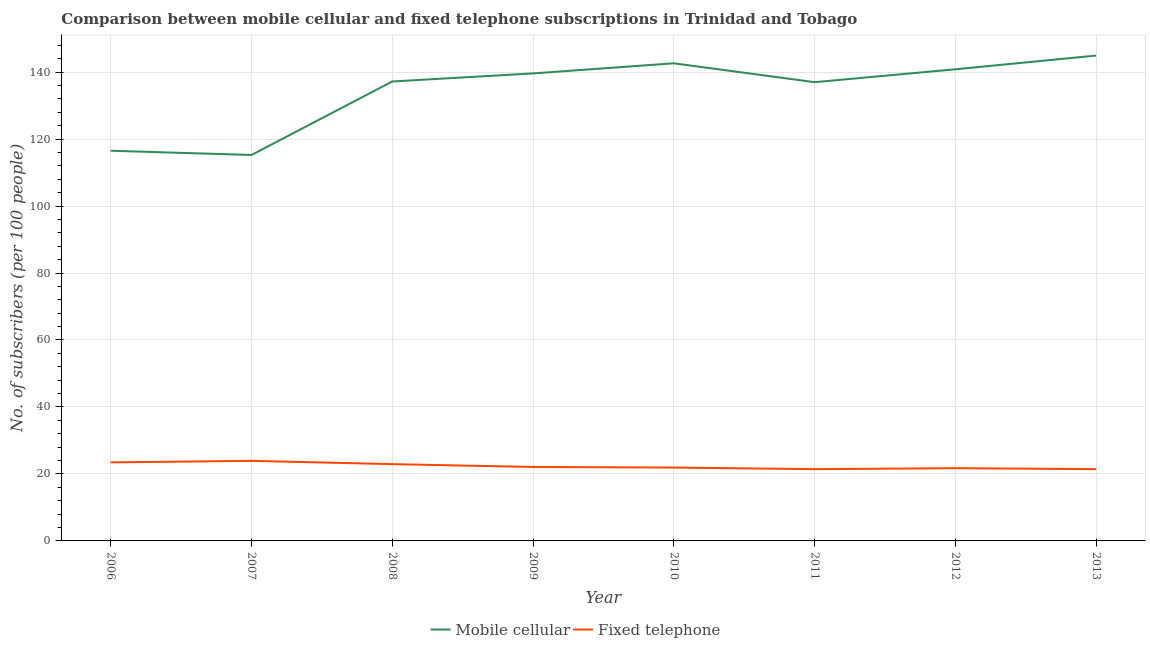How many different coloured lines are there?
Keep it short and to the point. 2. Is the number of lines equal to the number of legend labels?
Give a very brief answer. Yes. What is the number of fixed telephone subscribers in 2012?
Your answer should be very brief. 21.72. Across all years, what is the maximum number of fixed telephone subscribers?
Ensure brevity in your answer.  23.91. Across all years, what is the minimum number of fixed telephone subscribers?
Provide a succinct answer. 21.43. What is the total number of mobile cellular subscribers in the graph?
Provide a succinct answer. 1073.97. What is the difference between the number of fixed telephone subscribers in 2009 and that in 2013?
Your answer should be compact. 0.65. What is the difference between the number of fixed telephone subscribers in 2013 and the number of mobile cellular subscribers in 2010?
Provide a short and direct response. -121.19. What is the average number of mobile cellular subscribers per year?
Ensure brevity in your answer.  134.25. In the year 2011, what is the difference between the number of fixed telephone subscribers and number of mobile cellular subscribers?
Keep it short and to the point. -115.56. In how many years, is the number of fixed telephone subscribers greater than 104?
Make the answer very short. 0. What is the ratio of the number of mobile cellular subscribers in 2007 to that in 2010?
Ensure brevity in your answer.  0.81. Is the number of mobile cellular subscribers in 2009 less than that in 2012?
Make the answer very short. Yes. Is the difference between the number of mobile cellular subscribers in 2010 and 2013 greater than the difference between the number of fixed telephone subscribers in 2010 and 2013?
Provide a succinct answer. No. What is the difference between the highest and the second highest number of mobile cellular subscribers?
Ensure brevity in your answer.  2.31. What is the difference between the highest and the lowest number of fixed telephone subscribers?
Your response must be concise. 2.48. In how many years, is the number of mobile cellular subscribers greater than the average number of mobile cellular subscribers taken over all years?
Keep it short and to the point. 6. Is the sum of the number of fixed telephone subscribers in 2008 and 2010 greater than the maximum number of mobile cellular subscribers across all years?
Make the answer very short. No. Does the number of mobile cellular subscribers monotonically increase over the years?
Give a very brief answer. No. What is the difference between two consecutive major ticks on the Y-axis?
Ensure brevity in your answer.  20. Are the values on the major ticks of Y-axis written in scientific E-notation?
Offer a terse response. No. Does the graph contain any zero values?
Make the answer very short. No. Where does the legend appear in the graph?
Keep it short and to the point. Bottom center. How many legend labels are there?
Provide a short and direct response. 2. How are the legend labels stacked?
Ensure brevity in your answer.  Horizontal. What is the title of the graph?
Your answer should be very brief. Comparison between mobile cellular and fixed telephone subscriptions in Trinidad and Tobago. Does "Fraud firms" appear as one of the legend labels in the graph?
Offer a terse response. No. What is the label or title of the X-axis?
Provide a succinct answer. Year. What is the label or title of the Y-axis?
Your answer should be compact. No. of subscribers (per 100 people). What is the No. of subscribers (per 100 people) in Mobile cellular in 2006?
Keep it short and to the point. 116.52. What is the No. of subscribers (per 100 people) in Fixed telephone in 2006?
Make the answer very short. 23.46. What is the No. of subscribers (per 100 people) of Mobile cellular in 2007?
Your response must be concise. 115.25. What is the No. of subscribers (per 100 people) in Fixed telephone in 2007?
Your response must be concise. 23.91. What is the No. of subscribers (per 100 people) in Mobile cellular in 2008?
Offer a very short reply. 137.2. What is the No. of subscribers (per 100 people) of Fixed telephone in 2008?
Provide a short and direct response. 22.93. What is the No. of subscribers (per 100 people) of Mobile cellular in 2009?
Provide a succinct answer. 139.61. What is the No. of subscribers (per 100 people) of Fixed telephone in 2009?
Provide a short and direct response. 22.09. What is the No. of subscribers (per 100 people) in Mobile cellular in 2010?
Offer a terse response. 142.63. What is the No. of subscribers (per 100 people) in Fixed telephone in 2010?
Ensure brevity in your answer.  21.91. What is the No. of subscribers (per 100 people) of Mobile cellular in 2011?
Make the answer very short. 136.99. What is the No. of subscribers (per 100 people) of Fixed telephone in 2011?
Give a very brief answer. 21.43. What is the No. of subscribers (per 100 people) of Mobile cellular in 2012?
Offer a terse response. 140.84. What is the No. of subscribers (per 100 people) of Fixed telephone in 2012?
Ensure brevity in your answer.  21.72. What is the No. of subscribers (per 100 people) in Mobile cellular in 2013?
Make the answer very short. 144.94. What is the No. of subscribers (per 100 people) of Fixed telephone in 2013?
Your response must be concise. 21.43. Across all years, what is the maximum No. of subscribers (per 100 people) in Mobile cellular?
Offer a terse response. 144.94. Across all years, what is the maximum No. of subscribers (per 100 people) in Fixed telephone?
Provide a succinct answer. 23.91. Across all years, what is the minimum No. of subscribers (per 100 people) in Mobile cellular?
Offer a very short reply. 115.25. Across all years, what is the minimum No. of subscribers (per 100 people) in Fixed telephone?
Give a very brief answer. 21.43. What is the total No. of subscribers (per 100 people) of Mobile cellular in the graph?
Your answer should be very brief. 1073.97. What is the total No. of subscribers (per 100 people) of Fixed telephone in the graph?
Ensure brevity in your answer.  178.87. What is the difference between the No. of subscribers (per 100 people) of Mobile cellular in 2006 and that in 2007?
Your answer should be very brief. 1.27. What is the difference between the No. of subscribers (per 100 people) in Fixed telephone in 2006 and that in 2007?
Make the answer very short. -0.45. What is the difference between the No. of subscribers (per 100 people) in Mobile cellular in 2006 and that in 2008?
Your response must be concise. -20.68. What is the difference between the No. of subscribers (per 100 people) in Fixed telephone in 2006 and that in 2008?
Keep it short and to the point. 0.53. What is the difference between the No. of subscribers (per 100 people) of Mobile cellular in 2006 and that in 2009?
Your response must be concise. -23.09. What is the difference between the No. of subscribers (per 100 people) in Fixed telephone in 2006 and that in 2009?
Ensure brevity in your answer.  1.37. What is the difference between the No. of subscribers (per 100 people) in Mobile cellular in 2006 and that in 2010?
Ensure brevity in your answer.  -26.11. What is the difference between the No. of subscribers (per 100 people) in Fixed telephone in 2006 and that in 2010?
Your answer should be very brief. 1.55. What is the difference between the No. of subscribers (per 100 people) of Mobile cellular in 2006 and that in 2011?
Offer a terse response. -20.47. What is the difference between the No. of subscribers (per 100 people) of Fixed telephone in 2006 and that in 2011?
Ensure brevity in your answer.  2.03. What is the difference between the No. of subscribers (per 100 people) in Mobile cellular in 2006 and that in 2012?
Give a very brief answer. -24.32. What is the difference between the No. of subscribers (per 100 people) of Fixed telephone in 2006 and that in 2012?
Your answer should be very brief. 1.74. What is the difference between the No. of subscribers (per 100 people) of Mobile cellular in 2006 and that in 2013?
Your answer should be very brief. -28.42. What is the difference between the No. of subscribers (per 100 people) in Fixed telephone in 2006 and that in 2013?
Make the answer very short. 2.02. What is the difference between the No. of subscribers (per 100 people) of Mobile cellular in 2007 and that in 2008?
Provide a short and direct response. -21.95. What is the difference between the No. of subscribers (per 100 people) in Fixed telephone in 2007 and that in 2008?
Provide a short and direct response. 0.98. What is the difference between the No. of subscribers (per 100 people) in Mobile cellular in 2007 and that in 2009?
Offer a very short reply. -24.36. What is the difference between the No. of subscribers (per 100 people) in Fixed telephone in 2007 and that in 2009?
Provide a succinct answer. 1.83. What is the difference between the No. of subscribers (per 100 people) in Mobile cellular in 2007 and that in 2010?
Provide a short and direct response. -27.38. What is the difference between the No. of subscribers (per 100 people) of Fixed telephone in 2007 and that in 2010?
Provide a short and direct response. 2.01. What is the difference between the No. of subscribers (per 100 people) in Mobile cellular in 2007 and that in 2011?
Make the answer very short. -21.74. What is the difference between the No. of subscribers (per 100 people) of Fixed telephone in 2007 and that in 2011?
Your response must be concise. 2.48. What is the difference between the No. of subscribers (per 100 people) of Mobile cellular in 2007 and that in 2012?
Your answer should be compact. -25.59. What is the difference between the No. of subscribers (per 100 people) of Fixed telephone in 2007 and that in 2012?
Keep it short and to the point. 2.19. What is the difference between the No. of subscribers (per 100 people) in Mobile cellular in 2007 and that in 2013?
Your response must be concise. -29.69. What is the difference between the No. of subscribers (per 100 people) in Fixed telephone in 2007 and that in 2013?
Your answer should be compact. 2.48. What is the difference between the No. of subscribers (per 100 people) of Mobile cellular in 2008 and that in 2009?
Make the answer very short. -2.41. What is the difference between the No. of subscribers (per 100 people) of Fixed telephone in 2008 and that in 2009?
Your answer should be very brief. 0.84. What is the difference between the No. of subscribers (per 100 people) in Mobile cellular in 2008 and that in 2010?
Ensure brevity in your answer.  -5.43. What is the difference between the No. of subscribers (per 100 people) in Fixed telephone in 2008 and that in 2010?
Provide a short and direct response. 1.02. What is the difference between the No. of subscribers (per 100 people) of Mobile cellular in 2008 and that in 2011?
Provide a succinct answer. 0.21. What is the difference between the No. of subscribers (per 100 people) of Fixed telephone in 2008 and that in 2011?
Your answer should be very brief. 1.5. What is the difference between the No. of subscribers (per 100 people) in Mobile cellular in 2008 and that in 2012?
Provide a succinct answer. -3.65. What is the difference between the No. of subscribers (per 100 people) of Fixed telephone in 2008 and that in 2012?
Your answer should be very brief. 1.21. What is the difference between the No. of subscribers (per 100 people) of Mobile cellular in 2008 and that in 2013?
Give a very brief answer. -7.74. What is the difference between the No. of subscribers (per 100 people) of Fixed telephone in 2008 and that in 2013?
Ensure brevity in your answer.  1.49. What is the difference between the No. of subscribers (per 100 people) in Mobile cellular in 2009 and that in 2010?
Give a very brief answer. -3.02. What is the difference between the No. of subscribers (per 100 people) in Fixed telephone in 2009 and that in 2010?
Offer a terse response. 0.18. What is the difference between the No. of subscribers (per 100 people) in Mobile cellular in 2009 and that in 2011?
Your response must be concise. 2.62. What is the difference between the No. of subscribers (per 100 people) in Fixed telephone in 2009 and that in 2011?
Provide a short and direct response. 0.66. What is the difference between the No. of subscribers (per 100 people) in Mobile cellular in 2009 and that in 2012?
Ensure brevity in your answer.  -1.23. What is the difference between the No. of subscribers (per 100 people) of Fixed telephone in 2009 and that in 2012?
Provide a short and direct response. 0.37. What is the difference between the No. of subscribers (per 100 people) in Mobile cellular in 2009 and that in 2013?
Make the answer very short. -5.33. What is the difference between the No. of subscribers (per 100 people) in Fixed telephone in 2009 and that in 2013?
Provide a succinct answer. 0.65. What is the difference between the No. of subscribers (per 100 people) of Mobile cellular in 2010 and that in 2011?
Offer a very short reply. 5.64. What is the difference between the No. of subscribers (per 100 people) in Fixed telephone in 2010 and that in 2011?
Offer a very short reply. 0.48. What is the difference between the No. of subscribers (per 100 people) in Mobile cellular in 2010 and that in 2012?
Provide a short and direct response. 1.79. What is the difference between the No. of subscribers (per 100 people) of Fixed telephone in 2010 and that in 2012?
Give a very brief answer. 0.19. What is the difference between the No. of subscribers (per 100 people) of Mobile cellular in 2010 and that in 2013?
Provide a succinct answer. -2.31. What is the difference between the No. of subscribers (per 100 people) of Fixed telephone in 2010 and that in 2013?
Ensure brevity in your answer.  0.47. What is the difference between the No. of subscribers (per 100 people) of Mobile cellular in 2011 and that in 2012?
Keep it short and to the point. -3.85. What is the difference between the No. of subscribers (per 100 people) of Fixed telephone in 2011 and that in 2012?
Offer a terse response. -0.29. What is the difference between the No. of subscribers (per 100 people) in Mobile cellular in 2011 and that in 2013?
Your answer should be compact. -7.95. What is the difference between the No. of subscribers (per 100 people) of Fixed telephone in 2011 and that in 2013?
Provide a succinct answer. -0.01. What is the difference between the No. of subscribers (per 100 people) in Mobile cellular in 2012 and that in 2013?
Offer a very short reply. -4.1. What is the difference between the No. of subscribers (per 100 people) in Fixed telephone in 2012 and that in 2013?
Make the answer very short. 0.28. What is the difference between the No. of subscribers (per 100 people) in Mobile cellular in 2006 and the No. of subscribers (per 100 people) in Fixed telephone in 2007?
Give a very brief answer. 92.61. What is the difference between the No. of subscribers (per 100 people) of Mobile cellular in 2006 and the No. of subscribers (per 100 people) of Fixed telephone in 2008?
Make the answer very short. 93.59. What is the difference between the No. of subscribers (per 100 people) in Mobile cellular in 2006 and the No. of subscribers (per 100 people) in Fixed telephone in 2009?
Give a very brief answer. 94.43. What is the difference between the No. of subscribers (per 100 people) of Mobile cellular in 2006 and the No. of subscribers (per 100 people) of Fixed telephone in 2010?
Give a very brief answer. 94.61. What is the difference between the No. of subscribers (per 100 people) in Mobile cellular in 2006 and the No. of subscribers (per 100 people) in Fixed telephone in 2011?
Provide a succinct answer. 95.09. What is the difference between the No. of subscribers (per 100 people) in Mobile cellular in 2006 and the No. of subscribers (per 100 people) in Fixed telephone in 2012?
Your answer should be very brief. 94.8. What is the difference between the No. of subscribers (per 100 people) of Mobile cellular in 2006 and the No. of subscribers (per 100 people) of Fixed telephone in 2013?
Make the answer very short. 95.08. What is the difference between the No. of subscribers (per 100 people) in Mobile cellular in 2007 and the No. of subscribers (per 100 people) in Fixed telephone in 2008?
Provide a succinct answer. 92.32. What is the difference between the No. of subscribers (per 100 people) of Mobile cellular in 2007 and the No. of subscribers (per 100 people) of Fixed telephone in 2009?
Ensure brevity in your answer.  93.16. What is the difference between the No. of subscribers (per 100 people) in Mobile cellular in 2007 and the No. of subscribers (per 100 people) in Fixed telephone in 2010?
Your answer should be compact. 93.34. What is the difference between the No. of subscribers (per 100 people) of Mobile cellular in 2007 and the No. of subscribers (per 100 people) of Fixed telephone in 2011?
Give a very brief answer. 93.82. What is the difference between the No. of subscribers (per 100 people) in Mobile cellular in 2007 and the No. of subscribers (per 100 people) in Fixed telephone in 2012?
Your response must be concise. 93.53. What is the difference between the No. of subscribers (per 100 people) in Mobile cellular in 2007 and the No. of subscribers (per 100 people) in Fixed telephone in 2013?
Your answer should be very brief. 93.81. What is the difference between the No. of subscribers (per 100 people) of Mobile cellular in 2008 and the No. of subscribers (per 100 people) of Fixed telephone in 2009?
Offer a very short reply. 115.11. What is the difference between the No. of subscribers (per 100 people) in Mobile cellular in 2008 and the No. of subscribers (per 100 people) in Fixed telephone in 2010?
Offer a very short reply. 115.29. What is the difference between the No. of subscribers (per 100 people) of Mobile cellular in 2008 and the No. of subscribers (per 100 people) of Fixed telephone in 2011?
Give a very brief answer. 115.77. What is the difference between the No. of subscribers (per 100 people) in Mobile cellular in 2008 and the No. of subscribers (per 100 people) in Fixed telephone in 2012?
Offer a terse response. 115.48. What is the difference between the No. of subscribers (per 100 people) of Mobile cellular in 2008 and the No. of subscribers (per 100 people) of Fixed telephone in 2013?
Provide a succinct answer. 115.76. What is the difference between the No. of subscribers (per 100 people) of Mobile cellular in 2009 and the No. of subscribers (per 100 people) of Fixed telephone in 2010?
Provide a short and direct response. 117.7. What is the difference between the No. of subscribers (per 100 people) of Mobile cellular in 2009 and the No. of subscribers (per 100 people) of Fixed telephone in 2011?
Ensure brevity in your answer.  118.18. What is the difference between the No. of subscribers (per 100 people) in Mobile cellular in 2009 and the No. of subscribers (per 100 people) in Fixed telephone in 2012?
Offer a very short reply. 117.89. What is the difference between the No. of subscribers (per 100 people) in Mobile cellular in 2009 and the No. of subscribers (per 100 people) in Fixed telephone in 2013?
Your answer should be very brief. 118.17. What is the difference between the No. of subscribers (per 100 people) in Mobile cellular in 2010 and the No. of subscribers (per 100 people) in Fixed telephone in 2011?
Provide a short and direct response. 121.2. What is the difference between the No. of subscribers (per 100 people) in Mobile cellular in 2010 and the No. of subscribers (per 100 people) in Fixed telephone in 2012?
Give a very brief answer. 120.91. What is the difference between the No. of subscribers (per 100 people) of Mobile cellular in 2010 and the No. of subscribers (per 100 people) of Fixed telephone in 2013?
Make the answer very short. 121.19. What is the difference between the No. of subscribers (per 100 people) in Mobile cellular in 2011 and the No. of subscribers (per 100 people) in Fixed telephone in 2012?
Give a very brief answer. 115.27. What is the difference between the No. of subscribers (per 100 people) of Mobile cellular in 2011 and the No. of subscribers (per 100 people) of Fixed telephone in 2013?
Offer a terse response. 115.56. What is the difference between the No. of subscribers (per 100 people) of Mobile cellular in 2012 and the No. of subscribers (per 100 people) of Fixed telephone in 2013?
Offer a terse response. 119.41. What is the average No. of subscribers (per 100 people) of Mobile cellular per year?
Provide a succinct answer. 134.25. What is the average No. of subscribers (per 100 people) in Fixed telephone per year?
Ensure brevity in your answer.  22.36. In the year 2006, what is the difference between the No. of subscribers (per 100 people) in Mobile cellular and No. of subscribers (per 100 people) in Fixed telephone?
Offer a very short reply. 93.06. In the year 2007, what is the difference between the No. of subscribers (per 100 people) of Mobile cellular and No. of subscribers (per 100 people) of Fixed telephone?
Make the answer very short. 91.34. In the year 2008, what is the difference between the No. of subscribers (per 100 people) in Mobile cellular and No. of subscribers (per 100 people) in Fixed telephone?
Offer a terse response. 114.27. In the year 2009, what is the difference between the No. of subscribers (per 100 people) in Mobile cellular and No. of subscribers (per 100 people) in Fixed telephone?
Your response must be concise. 117.52. In the year 2010, what is the difference between the No. of subscribers (per 100 people) in Mobile cellular and No. of subscribers (per 100 people) in Fixed telephone?
Ensure brevity in your answer.  120.72. In the year 2011, what is the difference between the No. of subscribers (per 100 people) of Mobile cellular and No. of subscribers (per 100 people) of Fixed telephone?
Provide a succinct answer. 115.56. In the year 2012, what is the difference between the No. of subscribers (per 100 people) of Mobile cellular and No. of subscribers (per 100 people) of Fixed telephone?
Offer a terse response. 119.12. In the year 2013, what is the difference between the No. of subscribers (per 100 people) of Mobile cellular and No. of subscribers (per 100 people) of Fixed telephone?
Your answer should be very brief. 123.51. What is the ratio of the No. of subscribers (per 100 people) in Mobile cellular in 2006 to that in 2007?
Your answer should be compact. 1.01. What is the ratio of the No. of subscribers (per 100 people) in Mobile cellular in 2006 to that in 2008?
Provide a short and direct response. 0.85. What is the ratio of the No. of subscribers (per 100 people) in Fixed telephone in 2006 to that in 2008?
Your response must be concise. 1.02. What is the ratio of the No. of subscribers (per 100 people) in Mobile cellular in 2006 to that in 2009?
Keep it short and to the point. 0.83. What is the ratio of the No. of subscribers (per 100 people) of Fixed telephone in 2006 to that in 2009?
Keep it short and to the point. 1.06. What is the ratio of the No. of subscribers (per 100 people) in Mobile cellular in 2006 to that in 2010?
Make the answer very short. 0.82. What is the ratio of the No. of subscribers (per 100 people) of Fixed telephone in 2006 to that in 2010?
Your answer should be compact. 1.07. What is the ratio of the No. of subscribers (per 100 people) in Mobile cellular in 2006 to that in 2011?
Keep it short and to the point. 0.85. What is the ratio of the No. of subscribers (per 100 people) of Fixed telephone in 2006 to that in 2011?
Your answer should be very brief. 1.09. What is the ratio of the No. of subscribers (per 100 people) in Mobile cellular in 2006 to that in 2012?
Give a very brief answer. 0.83. What is the ratio of the No. of subscribers (per 100 people) in Mobile cellular in 2006 to that in 2013?
Offer a terse response. 0.8. What is the ratio of the No. of subscribers (per 100 people) in Fixed telephone in 2006 to that in 2013?
Offer a very short reply. 1.09. What is the ratio of the No. of subscribers (per 100 people) of Mobile cellular in 2007 to that in 2008?
Offer a very short reply. 0.84. What is the ratio of the No. of subscribers (per 100 people) of Fixed telephone in 2007 to that in 2008?
Offer a terse response. 1.04. What is the ratio of the No. of subscribers (per 100 people) in Mobile cellular in 2007 to that in 2009?
Your answer should be compact. 0.83. What is the ratio of the No. of subscribers (per 100 people) in Fixed telephone in 2007 to that in 2009?
Ensure brevity in your answer.  1.08. What is the ratio of the No. of subscribers (per 100 people) in Mobile cellular in 2007 to that in 2010?
Offer a very short reply. 0.81. What is the ratio of the No. of subscribers (per 100 people) of Fixed telephone in 2007 to that in 2010?
Offer a very short reply. 1.09. What is the ratio of the No. of subscribers (per 100 people) of Mobile cellular in 2007 to that in 2011?
Keep it short and to the point. 0.84. What is the ratio of the No. of subscribers (per 100 people) of Fixed telephone in 2007 to that in 2011?
Provide a succinct answer. 1.12. What is the ratio of the No. of subscribers (per 100 people) of Mobile cellular in 2007 to that in 2012?
Offer a terse response. 0.82. What is the ratio of the No. of subscribers (per 100 people) in Fixed telephone in 2007 to that in 2012?
Offer a very short reply. 1.1. What is the ratio of the No. of subscribers (per 100 people) in Mobile cellular in 2007 to that in 2013?
Offer a very short reply. 0.8. What is the ratio of the No. of subscribers (per 100 people) in Fixed telephone in 2007 to that in 2013?
Provide a short and direct response. 1.12. What is the ratio of the No. of subscribers (per 100 people) in Mobile cellular in 2008 to that in 2009?
Your answer should be compact. 0.98. What is the ratio of the No. of subscribers (per 100 people) of Fixed telephone in 2008 to that in 2009?
Provide a short and direct response. 1.04. What is the ratio of the No. of subscribers (per 100 people) of Mobile cellular in 2008 to that in 2010?
Your answer should be very brief. 0.96. What is the ratio of the No. of subscribers (per 100 people) of Fixed telephone in 2008 to that in 2010?
Ensure brevity in your answer.  1.05. What is the ratio of the No. of subscribers (per 100 people) in Mobile cellular in 2008 to that in 2011?
Provide a succinct answer. 1. What is the ratio of the No. of subscribers (per 100 people) in Fixed telephone in 2008 to that in 2011?
Provide a short and direct response. 1.07. What is the ratio of the No. of subscribers (per 100 people) in Mobile cellular in 2008 to that in 2012?
Keep it short and to the point. 0.97. What is the ratio of the No. of subscribers (per 100 people) of Fixed telephone in 2008 to that in 2012?
Offer a terse response. 1.06. What is the ratio of the No. of subscribers (per 100 people) of Mobile cellular in 2008 to that in 2013?
Keep it short and to the point. 0.95. What is the ratio of the No. of subscribers (per 100 people) of Fixed telephone in 2008 to that in 2013?
Provide a short and direct response. 1.07. What is the ratio of the No. of subscribers (per 100 people) of Mobile cellular in 2009 to that in 2010?
Give a very brief answer. 0.98. What is the ratio of the No. of subscribers (per 100 people) in Fixed telephone in 2009 to that in 2010?
Your answer should be compact. 1.01. What is the ratio of the No. of subscribers (per 100 people) of Mobile cellular in 2009 to that in 2011?
Give a very brief answer. 1.02. What is the ratio of the No. of subscribers (per 100 people) in Fixed telephone in 2009 to that in 2011?
Ensure brevity in your answer.  1.03. What is the ratio of the No. of subscribers (per 100 people) of Mobile cellular in 2009 to that in 2012?
Keep it short and to the point. 0.99. What is the ratio of the No. of subscribers (per 100 people) in Fixed telephone in 2009 to that in 2012?
Give a very brief answer. 1.02. What is the ratio of the No. of subscribers (per 100 people) of Mobile cellular in 2009 to that in 2013?
Your answer should be compact. 0.96. What is the ratio of the No. of subscribers (per 100 people) of Fixed telephone in 2009 to that in 2013?
Give a very brief answer. 1.03. What is the ratio of the No. of subscribers (per 100 people) of Mobile cellular in 2010 to that in 2011?
Your answer should be compact. 1.04. What is the ratio of the No. of subscribers (per 100 people) in Fixed telephone in 2010 to that in 2011?
Give a very brief answer. 1.02. What is the ratio of the No. of subscribers (per 100 people) in Mobile cellular in 2010 to that in 2012?
Your answer should be compact. 1.01. What is the ratio of the No. of subscribers (per 100 people) in Fixed telephone in 2010 to that in 2012?
Your response must be concise. 1.01. What is the ratio of the No. of subscribers (per 100 people) of Mobile cellular in 2010 to that in 2013?
Provide a short and direct response. 0.98. What is the ratio of the No. of subscribers (per 100 people) in Mobile cellular in 2011 to that in 2012?
Make the answer very short. 0.97. What is the ratio of the No. of subscribers (per 100 people) of Fixed telephone in 2011 to that in 2012?
Offer a terse response. 0.99. What is the ratio of the No. of subscribers (per 100 people) of Mobile cellular in 2011 to that in 2013?
Your answer should be very brief. 0.95. What is the ratio of the No. of subscribers (per 100 people) in Mobile cellular in 2012 to that in 2013?
Provide a succinct answer. 0.97. What is the ratio of the No. of subscribers (per 100 people) of Fixed telephone in 2012 to that in 2013?
Your answer should be very brief. 1.01. What is the difference between the highest and the second highest No. of subscribers (per 100 people) in Mobile cellular?
Your answer should be compact. 2.31. What is the difference between the highest and the second highest No. of subscribers (per 100 people) in Fixed telephone?
Provide a succinct answer. 0.45. What is the difference between the highest and the lowest No. of subscribers (per 100 people) of Mobile cellular?
Your answer should be compact. 29.69. What is the difference between the highest and the lowest No. of subscribers (per 100 people) of Fixed telephone?
Keep it short and to the point. 2.48. 